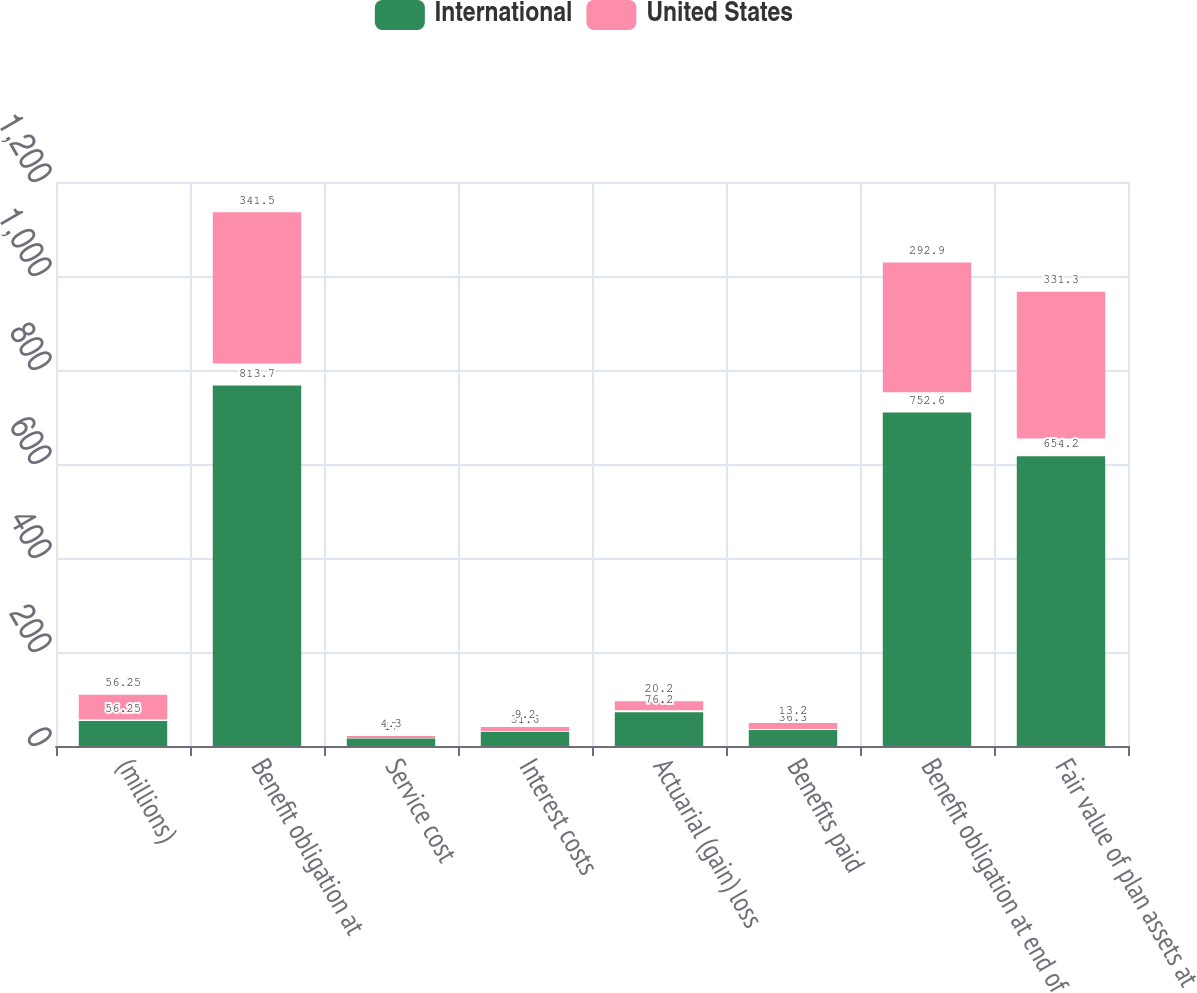Convert chart to OTSL. <chart><loc_0><loc_0><loc_500><loc_500><stacked_bar_chart><ecel><fcel>(millions)<fcel>Benefit obligation at<fcel>Service cost<fcel>Interest costs<fcel>Actuarial (gain) loss<fcel>Benefits paid<fcel>Benefit obligation at end of<fcel>Fair value of plan assets at<nl><fcel>International<fcel>56.25<fcel>813.7<fcel>17<fcel>31.6<fcel>76.2<fcel>36.3<fcel>752.6<fcel>654.2<nl><fcel>United States<fcel>56.25<fcel>341.5<fcel>4.3<fcel>9.2<fcel>20.2<fcel>13.2<fcel>292.9<fcel>331.3<nl></chart> 